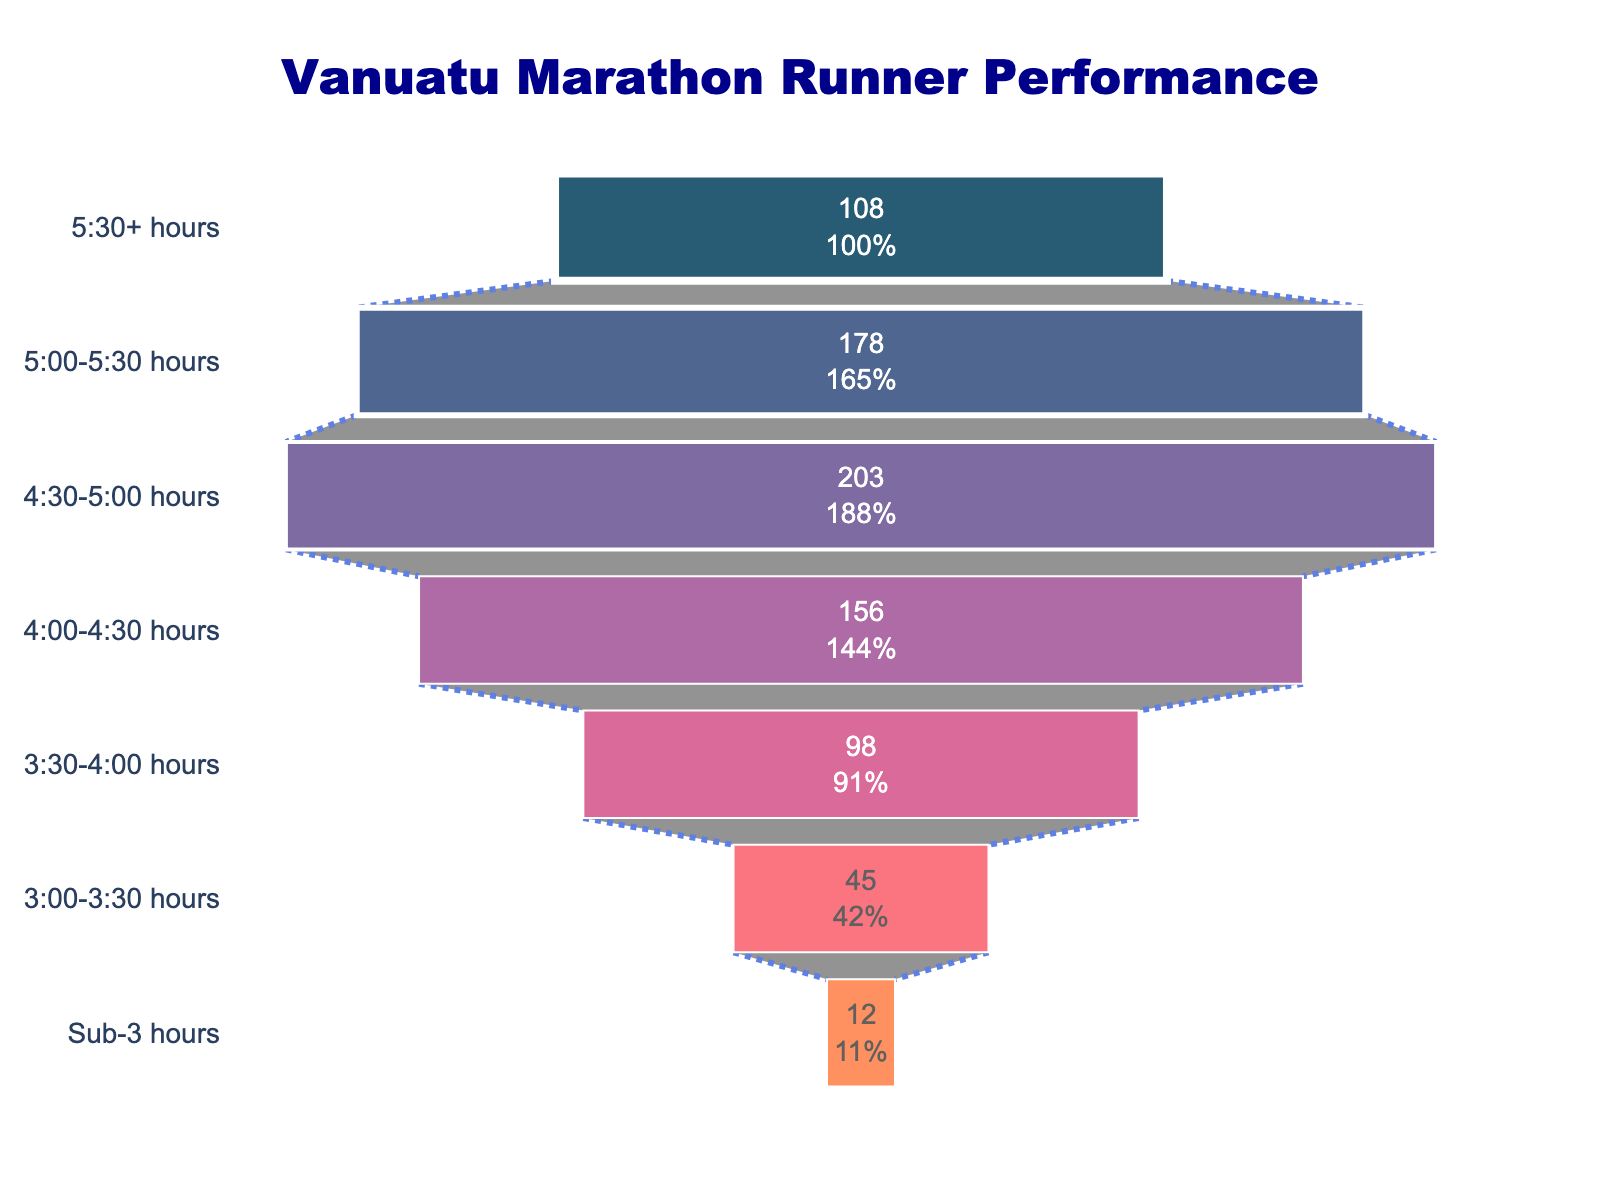What's the total number of marathon runners recorded in the chart? To find the total number of runners, sum up the number of runners in each category: 12 + 45 + 98 + 156 + 203 + 178 + 108.
Answer: 800 Which category has the highest number of runners? By looking at the length of each bar in the funnel chart, the longest bar represents the category with the most runners. "4:30-5:00 hours" has the longest bar with 203 runners.
Answer: 4:30-5:00 hours What percentage of total runners finished within 3:00 to 3:30 hours? Divide the number of runners in the "3:00-3:30 hours" category by the total number of runners and multiply by 100 to get the percentage: (45 / 800) * 100.
Answer: 5.625% How many more runners finished between "4:30-5:00 hours" than "Sub-3 hours"? Subtract the number of runners in "Sub-3 hours" from those in "4:30-5:00 hours": 203 - 12.
Answer: 191 Which two consecutive categories have the smallest difference in the number of runners? Calculate the differences between consecutive categories: (45-12), (98-45), (156-98), (203-156), (178-203), and (108-178). The smallest difference is between "5:00-5:30 hours" and "5:30+ hours", which is 178 - 108.
Answer: 5:00-5:30 hours and 5:30+ hours What is the average number of runners per category? Sum the number of runners across all categories and divide by the number of categories (7): (12 + 45 + 98 + 156 + 203 + 178 + 108) / 7.
Answer: Approximately 114.29 Which category has a darker color shade than “3:00-3:30 hours”? The color shade darkens as we move up the categories in the chart and "Sub-3 hours" category has a darker color than "3:00-3:30 hours".
Answer: Sub-3 hours How does the number of runners in the "4:00-4:30 hours" category compare to those in the "3:30-4:00 hours" category? Compare the lengths of the bars. "4:00-4:30 hours" has more runners (156) compared to "3:30-4:00 hours" (98).
Answer: More What is the cumulative number of runners who finished at or before 3:30 hours? Add the number of runners in "Sub-3 hours" and "3:00-3:30 hours": 12 + 45.
Answer: 57 Which category follows directly after "4:00-4:30 hours" in terms of increasing performance time? Following the sequence on the y-axis from "4:00-4:30 hours" upwards, the next category is "4:30-5:00 hours".
Answer: 4:30-5:00 hours 